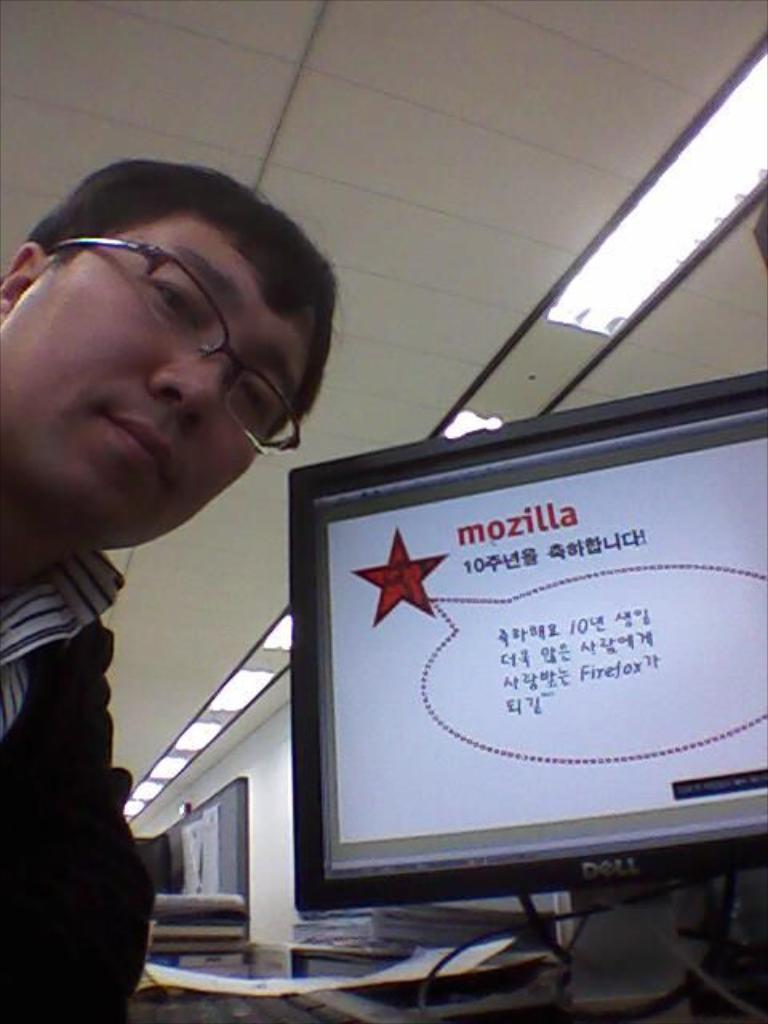Who is present in the image? There is a man in the image. Where is the man located in the image? The man is on the left side of the image. What can be seen beside the man? There is a desktop beside the man. What is visible above the man and the desktop? There is a ceiling in the image, and it has lights. What type of zipper can be seen on the man's clothing in the image? There is no zipper visible on the man's clothing in the image. What kind of ray is flying above the man in the image? There are no rays present in the image; it is an indoor setting with a ceiling and lights. 